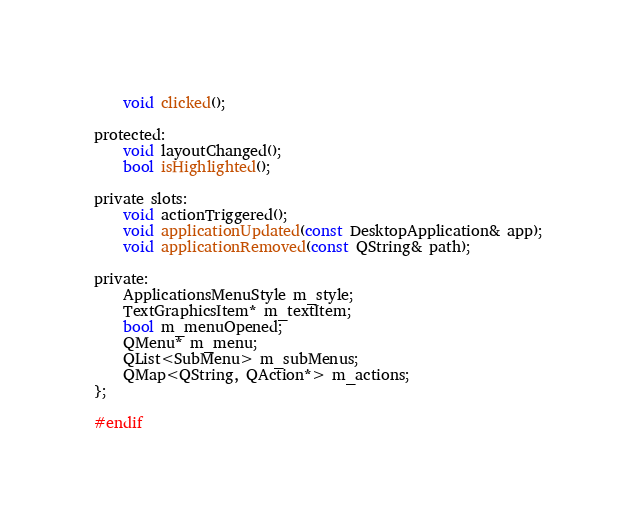<code> <loc_0><loc_0><loc_500><loc_500><_C_>    void clicked();

protected:
    void layoutChanged();
    bool isHighlighted();

private slots:
    void actionTriggered();
    void applicationUpdated(const DesktopApplication& app);
    void applicationRemoved(const QString& path);

private:
    ApplicationsMenuStyle m_style;
    TextGraphicsItem* m_textItem;
    bool m_menuOpened;
    QMenu* m_menu;
    QList<SubMenu> m_subMenus;
    QMap<QString, QAction*> m_actions;
};

#endif
</code> 